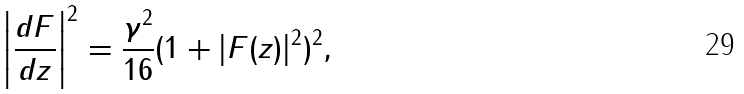<formula> <loc_0><loc_0><loc_500><loc_500>\left | \frac { d F } { d z } \right | ^ { 2 } = \frac { \gamma ^ { 2 } } { 1 6 } ( 1 + | F ( z ) | ^ { 2 } ) ^ { 2 } ,</formula> 